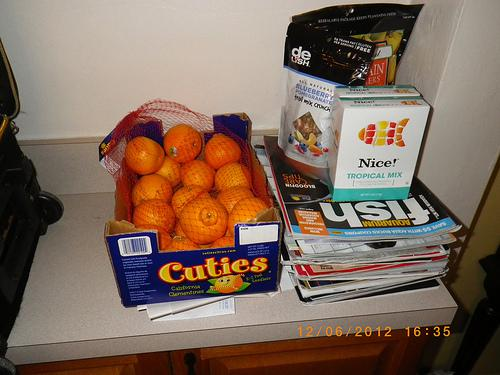Question: where was the picture taken?
Choices:
A. Beach.
B. Ocean.
C. In a kitchen.
D. Bathroom.
Answer with the letter. Answer: C Question: when was the photo taken?
Choices:
A. 18:47.
B. 15:15.
C. 17:19.
D. 16:35.
Answer with the letter. Answer: D Question: what date was the photo taken?
Choices:
A. 04/06/2013.
B. 05/06/2014.
C. 08/22/2015.
D. 12/06/2012.
Answer with the letter. Answer: D Question: what color are the clementines?
Choices:
A. Green.
B. Brown.
C. Black.
D. Orange.
Answer with the letter. Answer: D Question: what says Nice! on it?
Choices:
A. Package.
B. Wrapper.
C. Box.
D. Carton.
Answer with the letter. Answer: C 